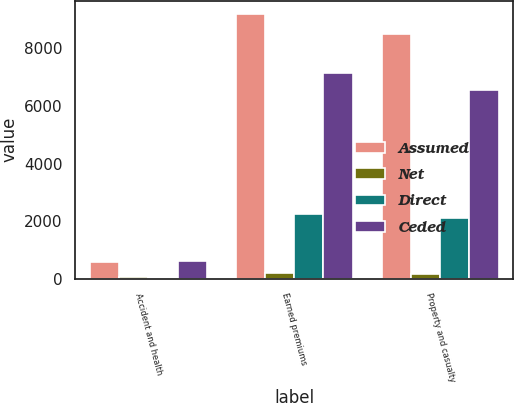Convert chart. <chart><loc_0><loc_0><loc_500><loc_500><stacked_bar_chart><ecel><fcel>Accident and health<fcel>Earned premiums<fcel>Property and casualty<nl><fcel>Assumed<fcel>592<fcel>9187<fcel>8496<nl><fcel>Net<fcel>46<fcel>210<fcel>164<nl><fcel>Direct<fcel>28<fcel>2247<fcel>2121<nl><fcel>Ceded<fcel>610<fcel>7150<fcel>6539<nl></chart> 